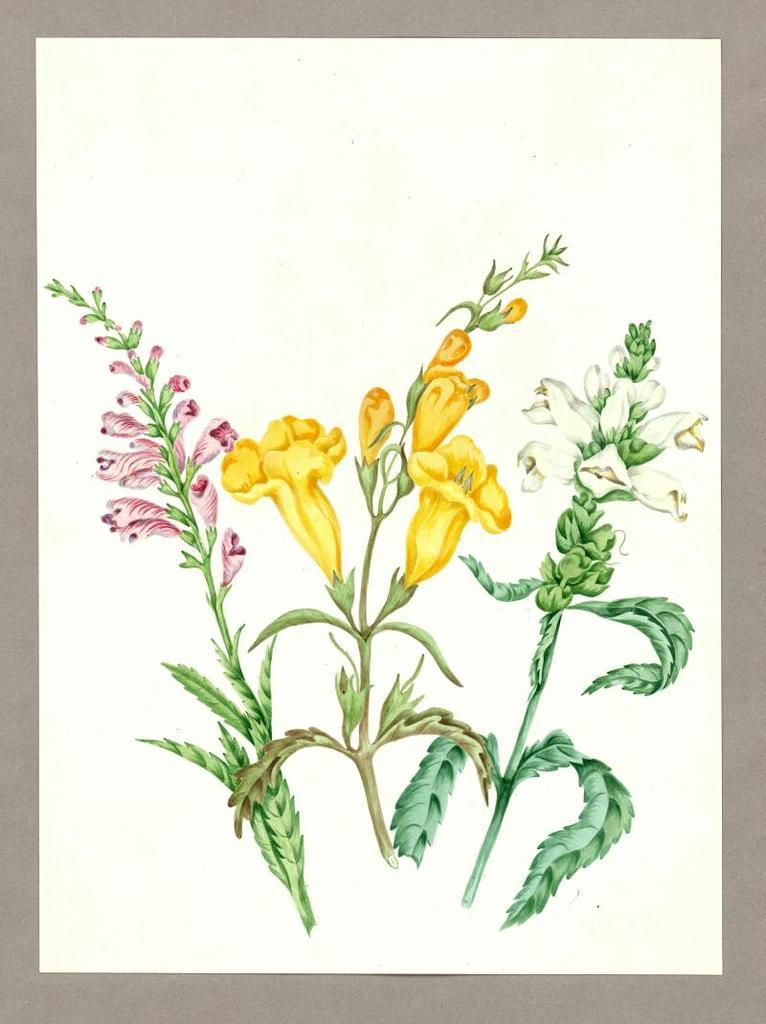What type of art is shown in the image? The image is an art piece on paper. How many atoms are depicted in the art? There are three atoms depicted in the art. What distinguishes each atom from the others? Each atom has a different type of flower. What other elements can be seen in the art? Green leaves are present in the art. What type of instrument is being played by the rose in the image? There is no rose or instrument present in the image; it features an art piece with three atoms and green leaves. 